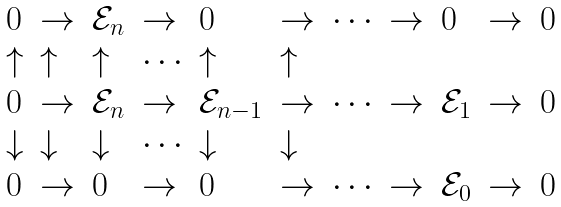Convert formula to latex. <formula><loc_0><loc_0><loc_500><loc_500>\begin{array} { l l l l l l l l l l l } { 0 } & { \to } & { { \mathcal { E } } _ { n } } & { \to } & { 0 } & { \to } & { \cdots } & { \to } & { 0 } & { \to } & { 0 } \\ { \uparrow } & { \uparrow } & { \uparrow } & { \cdots } & { \uparrow } & { \uparrow } \\ { 0 } & { \to } & { { \mathcal { E } } _ { n } } & { \to } & { { \mathcal { E } } _ { n - 1 } } & { \to } & { \cdots } & { \to } & { { \mathcal { E } } _ { 1 } } & { \to } & { 0 } \\ { \downarrow } & { \downarrow } & { \downarrow } & { \cdots } & { \downarrow } & { \downarrow } \\ { 0 } & { \to } & { 0 } & { \to } & { 0 } & { \to } & { \cdots } & { \to } & { { \mathcal { E } } _ { 0 } } & { \to } & { 0 } \end{array}</formula> 